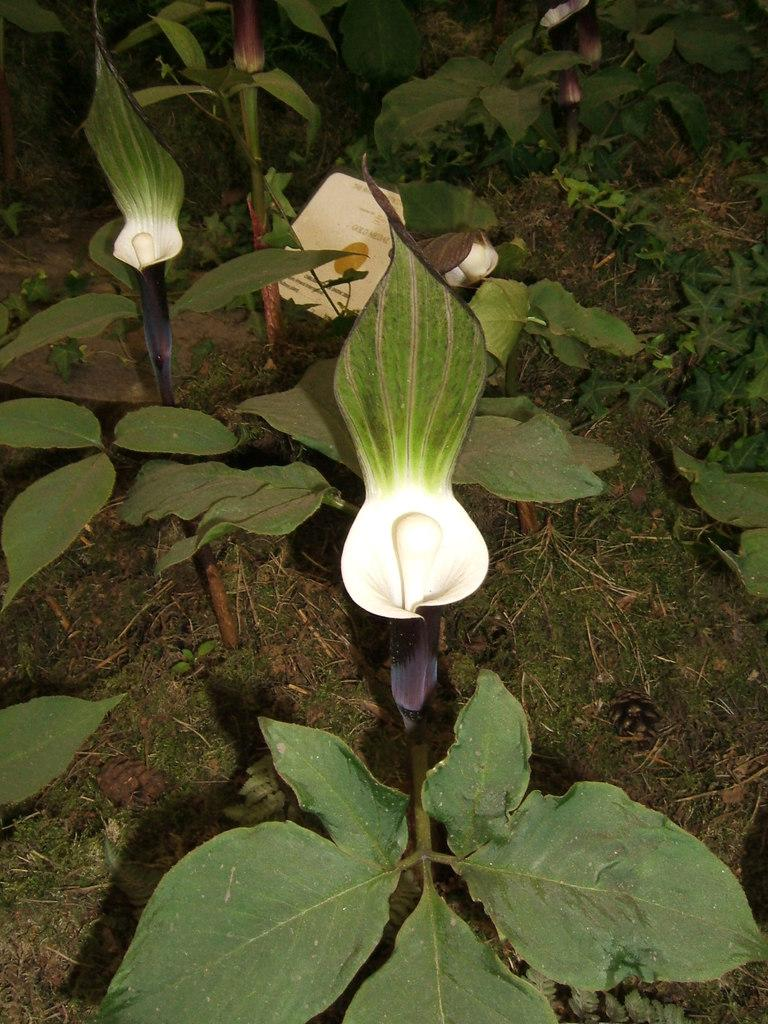What type of plants are on the floor in the image? There are small plants on the floor in the image. What colors are the flowers on the plants? The flowers on the plants have green and violet colors. What is the base material for the plants in the image? There is soil in the image. What type of vegetation is also present in the image? There is grass in the image. Are there any sticks used as support for the plants in the image? There is no mention of sticks being used as support for the plants in the image. 